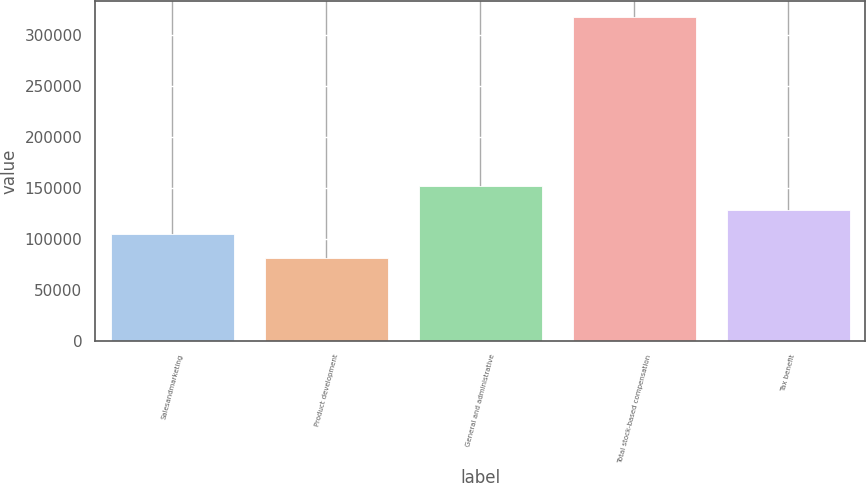<chart> <loc_0><loc_0><loc_500><loc_500><bar_chart><fcel>Salesandmarketing<fcel>Product development<fcel>General and administrative<fcel>Total stock-based compensation<fcel>Tax benefit<nl><fcel>105081<fcel>81489<fcel>152265<fcel>317410<fcel>128673<nl></chart> 